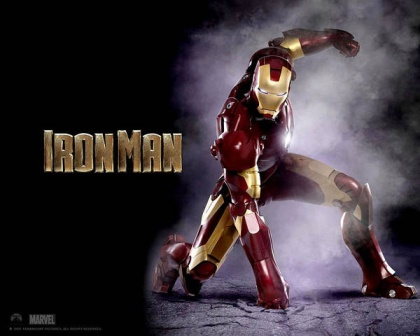Imagine Iron Man's suit could talk. What kind of personality might it have, and how would it interact with Tony? If Iron Man's suit could talk, it might possess a personality similar to JARVIS—calm, intelligent, and occasionally witty. It could provide real-time feedback, suggest tactical maneuvers during combat, and even engage in banter with Tony to keep his spirits up. The suit might respond to Tony’s commands with a dash of humor, offer comforting words during tense moments, and display a deep understanding of Tony's habits and preferences, making it an indispensable ally and friend. 